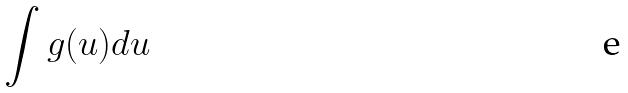Convert formula to latex. <formula><loc_0><loc_0><loc_500><loc_500>\int g ( u ) d u</formula> 